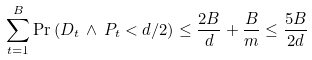Convert formula to latex. <formula><loc_0><loc_0><loc_500><loc_500>\sum _ { t = 1 } ^ { B } \Pr \left ( D _ { t } \, \wedge \, P _ { t } < d / 2 \right ) \leq \frac { 2 B } { d } + \frac { B } { m } \leq \frac { 5 B } { 2 d }</formula> 